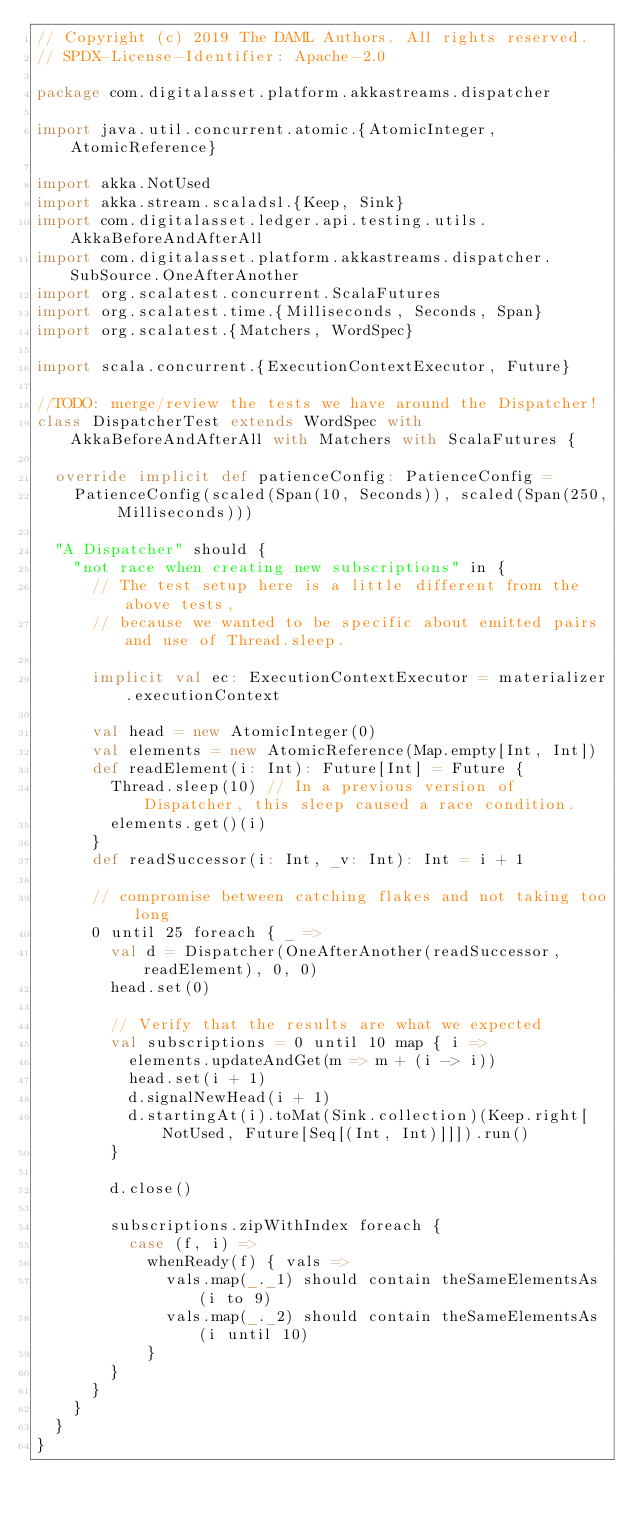Convert code to text. <code><loc_0><loc_0><loc_500><loc_500><_Scala_>// Copyright (c) 2019 The DAML Authors. All rights reserved.
// SPDX-License-Identifier: Apache-2.0

package com.digitalasset.platform.akkastreams.dispatcher

import java.util.concurrent.atomic.{AtomicInteger, AtomicReference}

import akka.NotUsed
import akka.stream.scaladsl.{Keep, Sink}
import com.digitalasset.ledger.api.testing.utils.AkkaBeforeAndAfterAll
import com.digitalasset.platform.akkastreams.dispatcher.SubSource.OneAfterAnother
import org.scalatest.concurrent.ScalaFutures
import org.scalatest.time.{Milliseconds, Seconds, Span}
import org.scalatest.{Matchers, WordSpec}

import scala.concurrent.{ExecutionContextExecutor, Future}

//TODO: merge/review the tests we have around the Dispatcher!
class DispatcherTest extends WordSpec with AkkaBeforeAndAfterAll with Matchers with ScalaFutures {

  override implicit def patienceConfig: PatienceConfig =
    PatienceConfig(scaled(Span(10, Seconds)), scaled(Span(250, Milliseconds)))

  "A Dispatcher" should {
    "not race when creating new subscriptions" in {
      // The test setup here is a little different from the above tests,
      // because we wanted to be specific about emitted pairs and use of Thread.sleep.

      implicit val ec: ExecutionContextExecutor = materializer.executionContext

      val head = new AtomicInteger(0)
      val elements = new AtomicReference(Map.empty[Int, Int])
      def readElement(i: Int): Future[Int] = Future {
        Thread.sleep(10) // In a previous version of Dispatcher, this sleep caused a race condition.
        elements.get()(i)
      }
      def readSuccessor(i: Int, _v: Int): Int = i + 1

      // compromise between catching flakes and not taking too long
      0 until 25 foreach { _ =>
        val d = Dispatcher(OneAfterAnother(readSuccessor, readElement), 0, 0)
        head.set(0)

        // Verify that the results are what we expected
        val subscriptions = 0 until 10 map { i =>
          elements.updateAndGet(m => m + (i -> i))
          head.set(i + 1)
          d.signalNewHead(i + 1)
          d.startingAt(i).toMat(Sink.collection)(Keep.right[NotUsed, Future[Seq[(Int, Int)]]]).run()
        }

        d.close()

        subscriptions.zipWithIndex foreach {
          case (f, i) =>
            whenReady(f) { vals =>
              vals.map(_._1) should contain theSameElementsAs (i to 9)
              vals.map(_._2) should contain theSameElementsAs (i until 10)
            }
        }
      }
    }
  }
}
</code> 